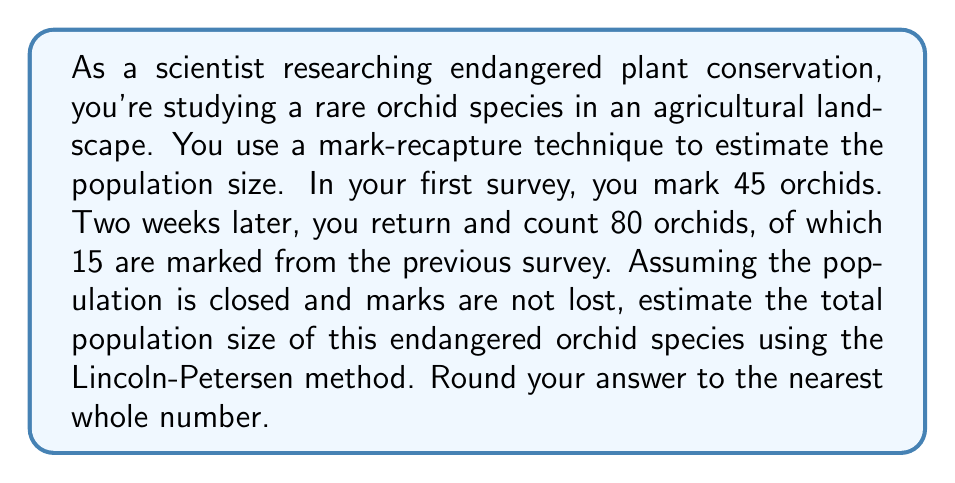Provide a solution to this math problem. To estimate the population size using the Lincoln-Petersen method, we use the following formula:

$$N = \frac{MC}{R}$$

Where:
$N$ = estimated population size
$M$ = number of individuals marked in the first sample
$C$ = total number of individuals caught in the second sample
$R$ = number of marked individuals recaptured in the second sample

Given:
$M = 45$ (orchids marked in first survey)
$C = 80$ (total orchids counted in second survey)
$R = 15$ (marked orchids recaptured in second survey)

Substituting these values into the formula:

$$N = \frac{45 \times 80}{15}$$

$$N = \frac{3600}{15}$$

$$N = 240$$

Therefore, the estimated population size of the endangered orchid species is 240.

Note: The Lincoln-Petersen method assumes a closed population (no births, deaths, immigration, or emigration between sampling periods), equal catchability of marked and unmarked individuals, and that marks are not lost or overlooked. In real-world scenarios, these assumptions may not always hold, and more complex models might be necessary for accurate population estimation.
Answer: 240 orchids 